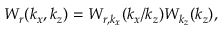<formula> <loc_0><loc_0><loc_500><loc_500>W _ { r } ( k _ { x } , k _ { z } ) = W _ { r , k _ { x } } ( k _ { x } / k _ { z } ) W _ { k _ { z } } ( k _ { z } ) ,</formula> 